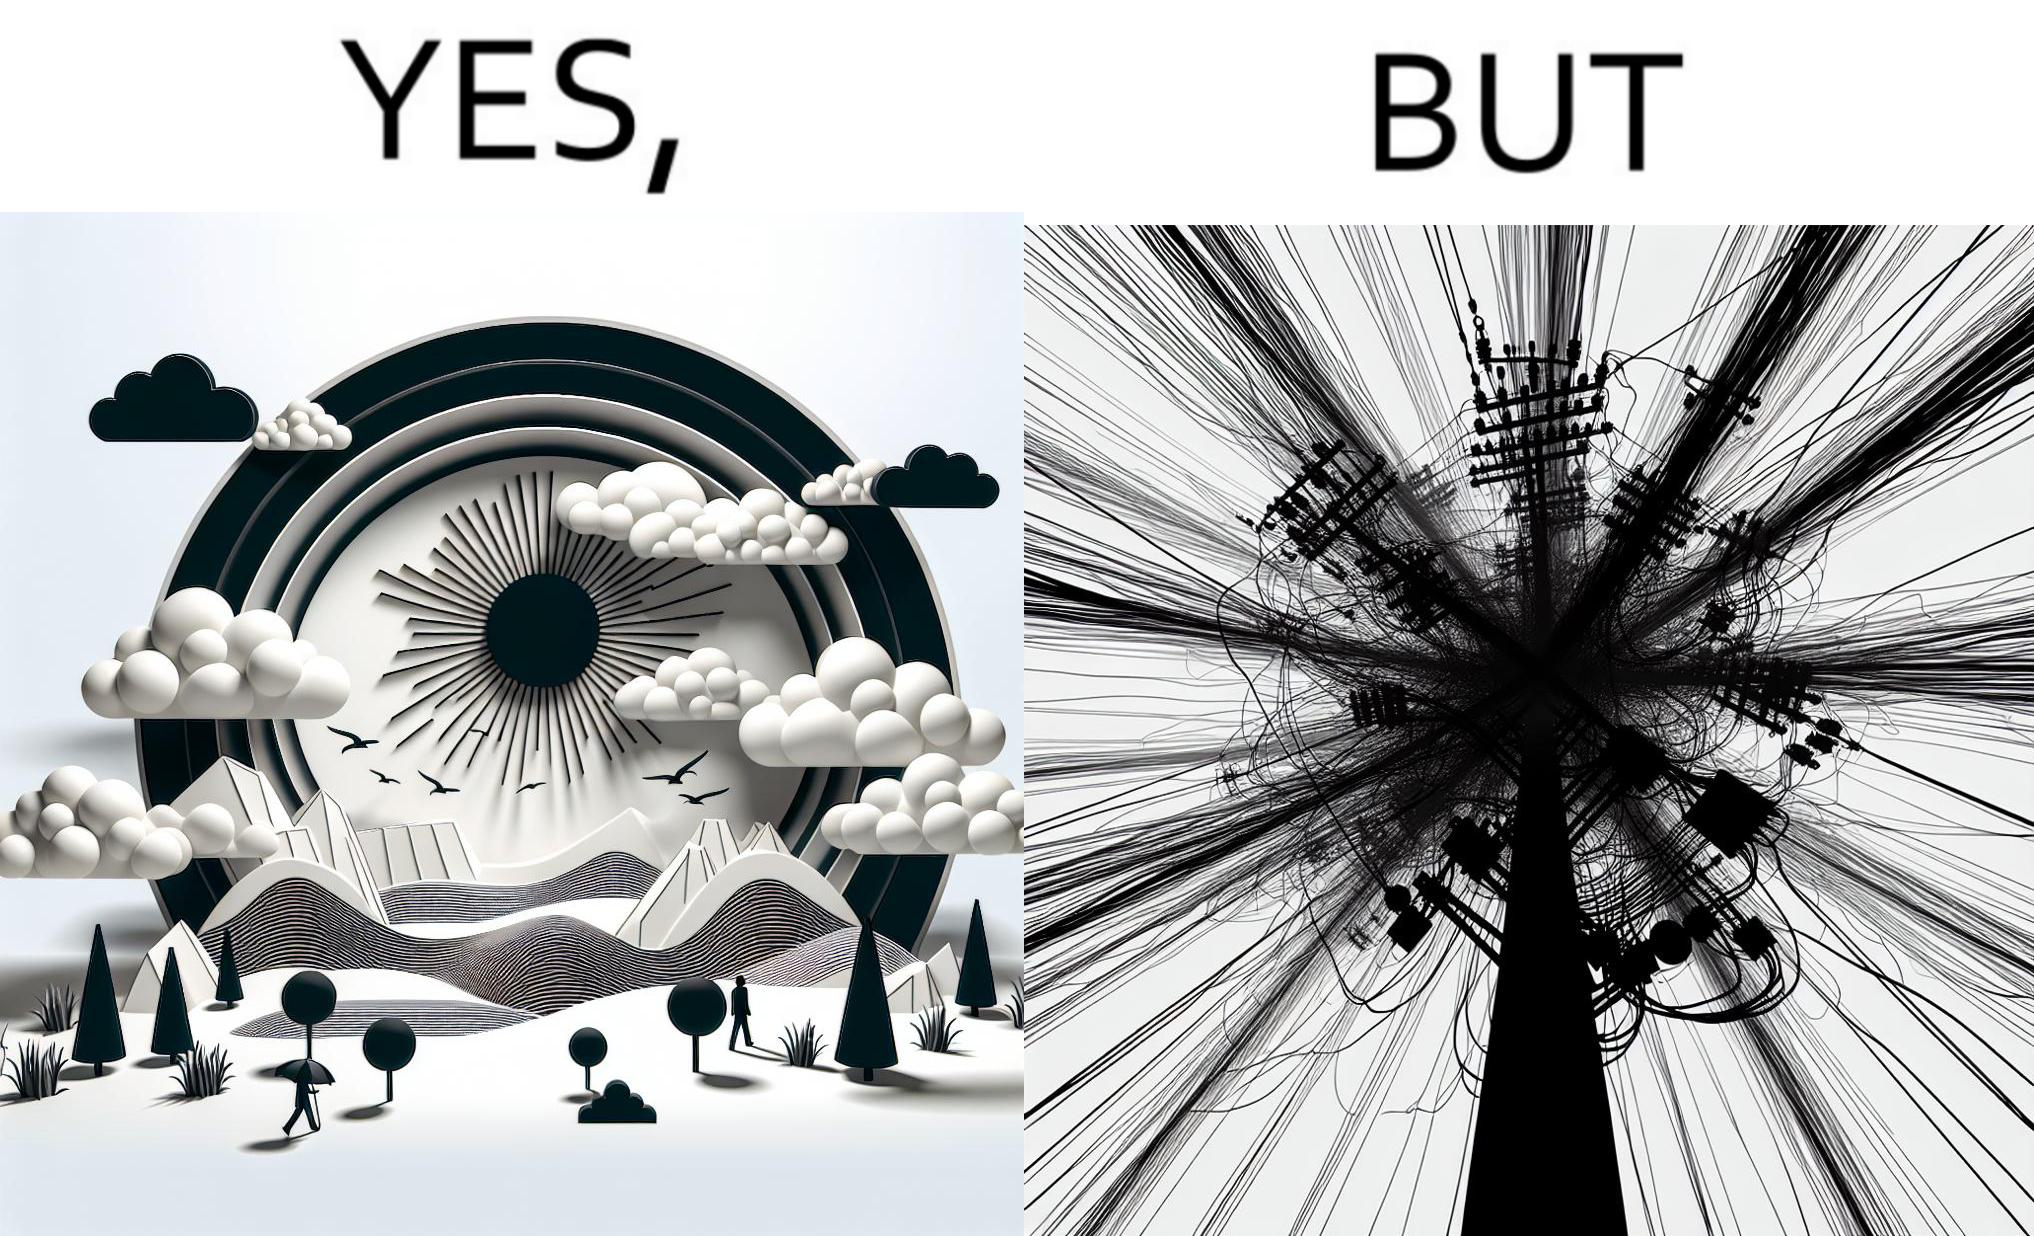What is shown in this image? The image is ironic, because in the first image clear sky is visible but in the second image the same view is getting blocked due to the electricity pole 